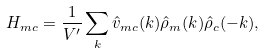<formula> <loc_0><loc_0><loc_500><loc_500>H _ { m c } = \frac { 1 } { V ^ { \prime } } \sum _ { k } \hat { v } _ { m c } ( k ) \hat { \rho } _ { m } ( { k } ) \hat { \rho } _ { c } ( - { k } ) ,</formula> 